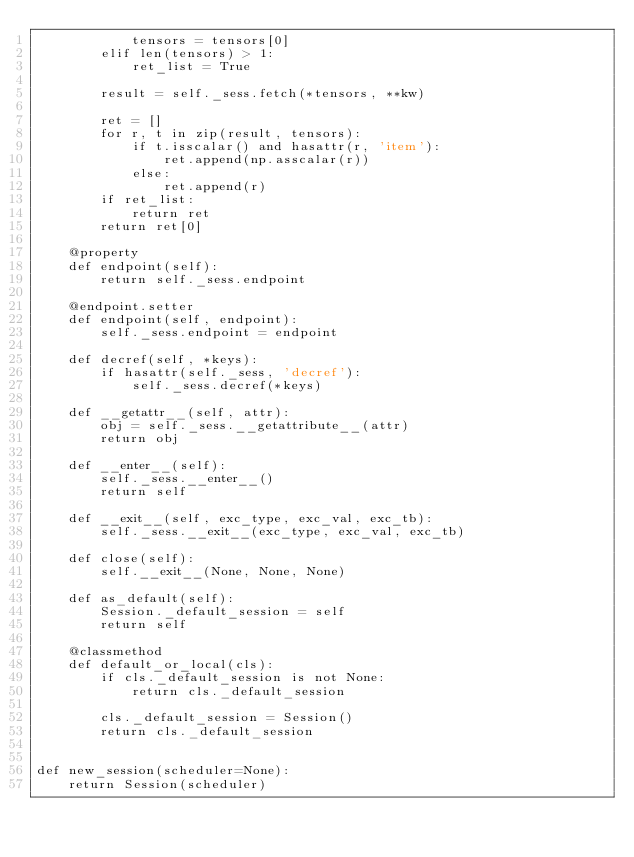<code> <loc_0><loc_0><loc_500><loc_500><_Python_>            tensors = tensors[0]
        elif len(tensors) > 1:
            ret_list = True

        result = self._sess.fetch(*tensors, **kw)

        ret = []
        for r, t in zip(result, tensors):
            if t.isscalar() and hasattr(r, 'item'):
                ret.append(np.asscalar(r))
            else:
                ret.append(r)
        if ret_list:
            return ret
        return ret[0]

    @property
    def endpoint(self):
        return self._sess.endpoint

    @endpoint.setter
    def endpoint(self, endpoint):
        self._sess.endpoint = endpoint

    def decref(self, *keys):
        if hasattr(self._sess, 'decref'):
            self._sess.decref(*keys)

    def __getattr__(self, attr):
        obj = self._sess.__getattribute__(attr)
        return obj

    def __enter__(self):
        self._sess.__enter__()
        return self

    def __exit__(self, exc_type, exc_val, exc_tb):
        self._sess.__exit__(exc_type, exc_val, exc_tb)

    def close(self):
        self.__exit__(None, None, None)

    def as_default(self):
        Session._default_session = self
        return self

    @classmethod
    def default_or_local(cls):
        if cls._default_session is not None:
            return cls._default_session

        cls._default_session = Session()
        return cls._default_session


def new_session(scheduler=None):
    return Session(scheduler)
</code> 